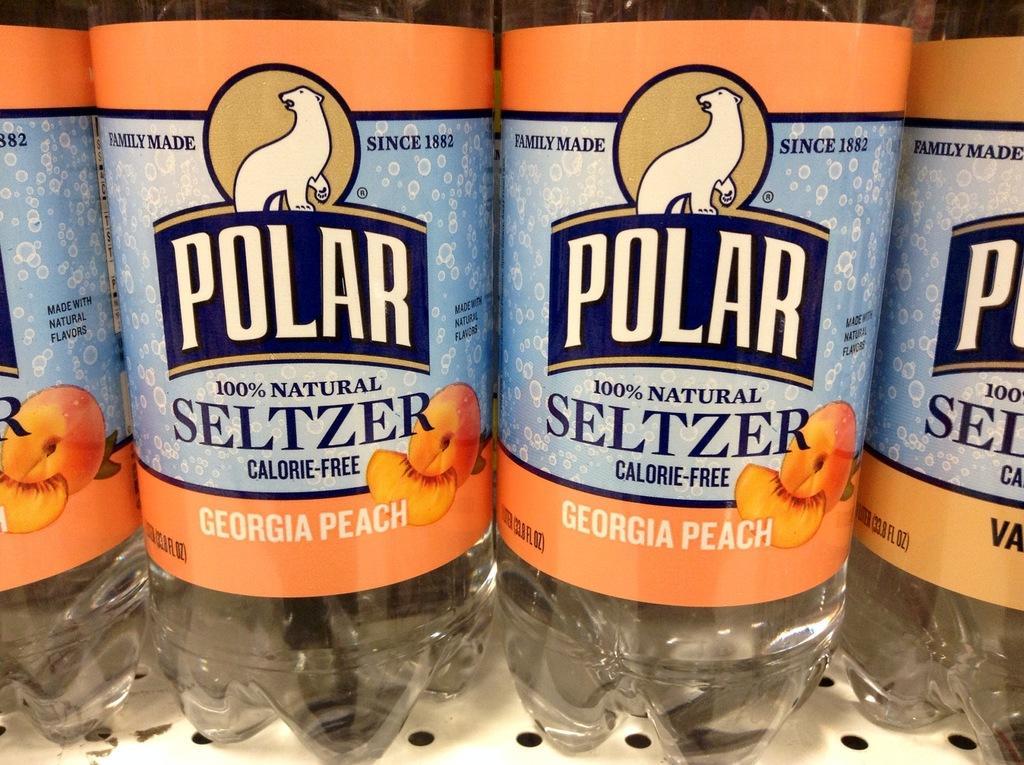Describe this image in one or two sentences. Here in this picture we can see number of bottles present in the rack over there. 